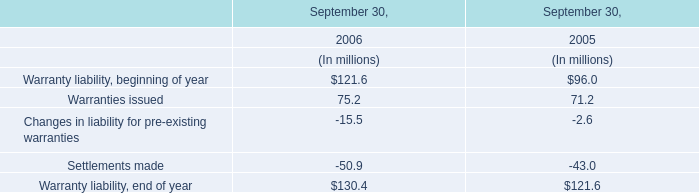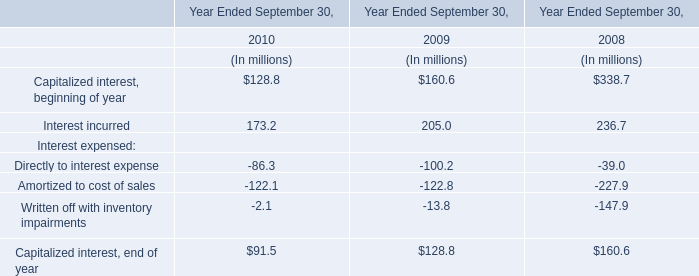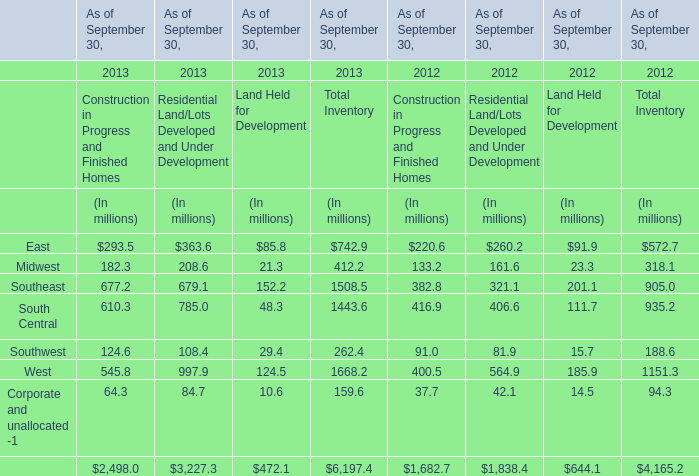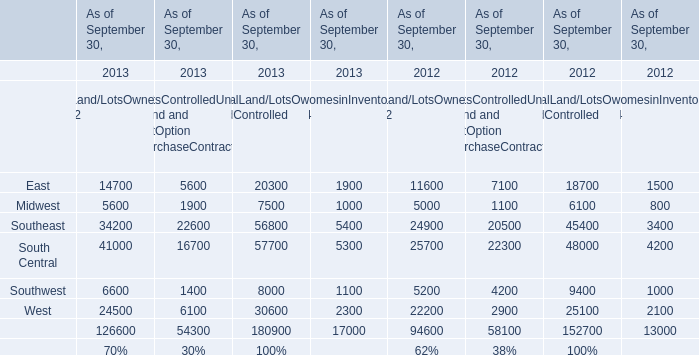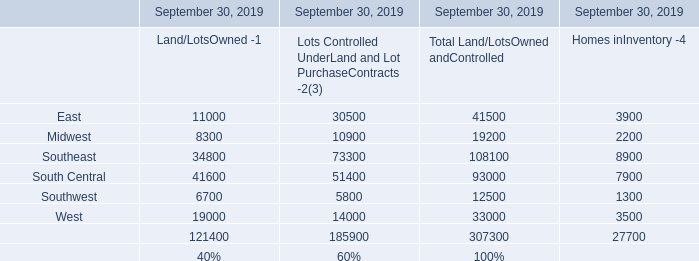Does the value of Midwest in total inventory in 2013 greater than that in 2012? 
Answer: No. 